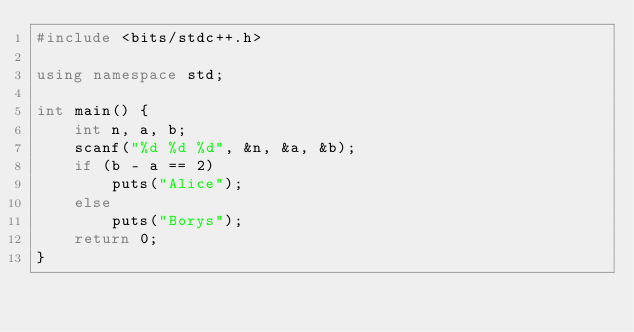Convert code to text. <code><loc_0><loc_0><loc_500><loc_500><_C++_>#include <bits/stdc++.h>

using namespace std;

int main() {
	int n, a, b;
	scanf("%d %d %d", &n, &a, &b);
	if (b - a == 2)
		puts("Alice");
	else 
		puts("Borys");
	return 0;
}</code> 